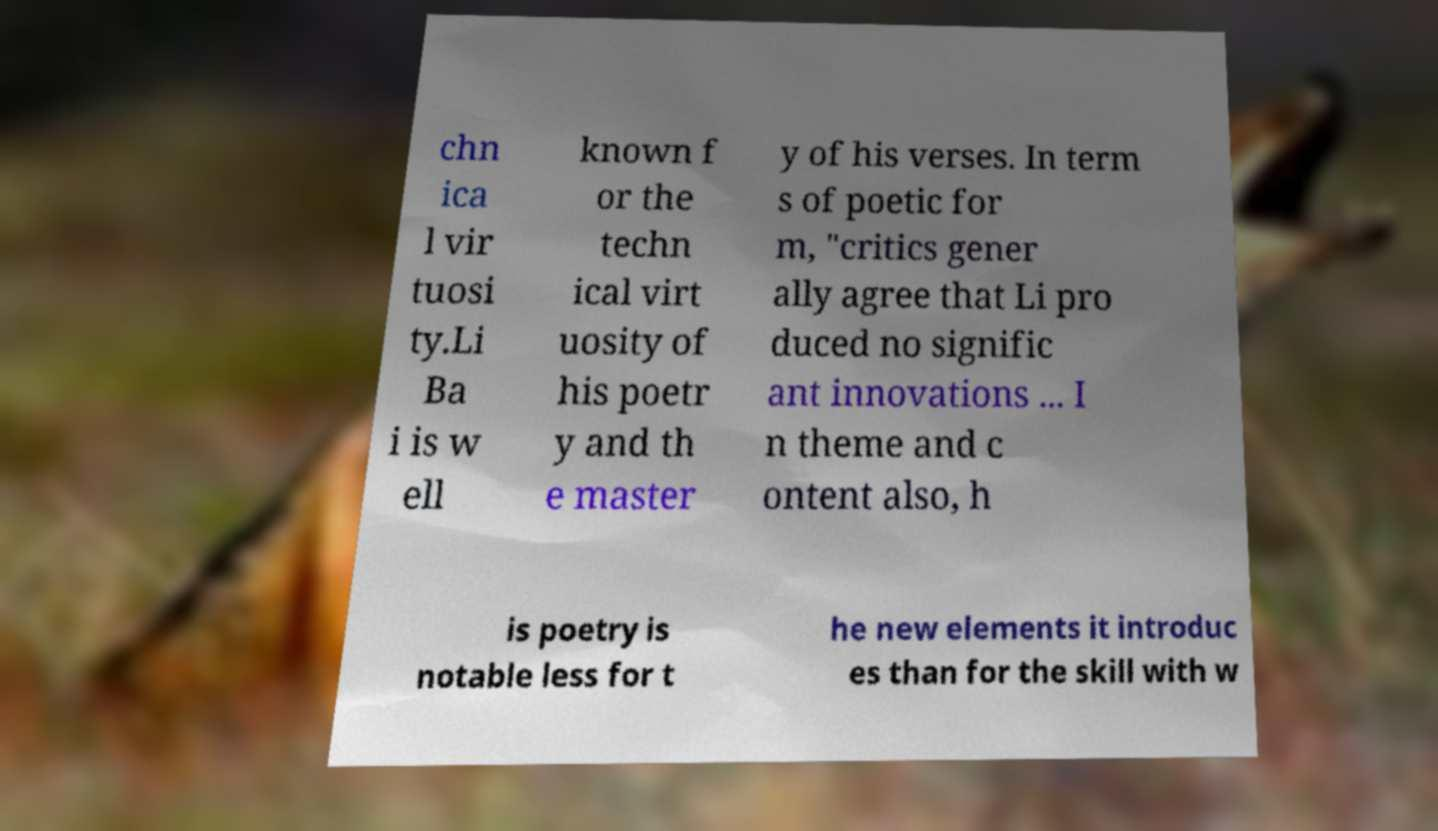Please identify and transcribe the text found in this image. chn ica l vir tuosi ty.Li Ba i is w ell known f or the techn ical virt uosity of his poetr y and th e master y of his verses. In term s of poetic for m, "critics gener ally agree that Li pro duced no signific ant innovations ... I n theme and c ontent also, h is poetry is notable less for t he new elements it introduc es than for the skill with w 